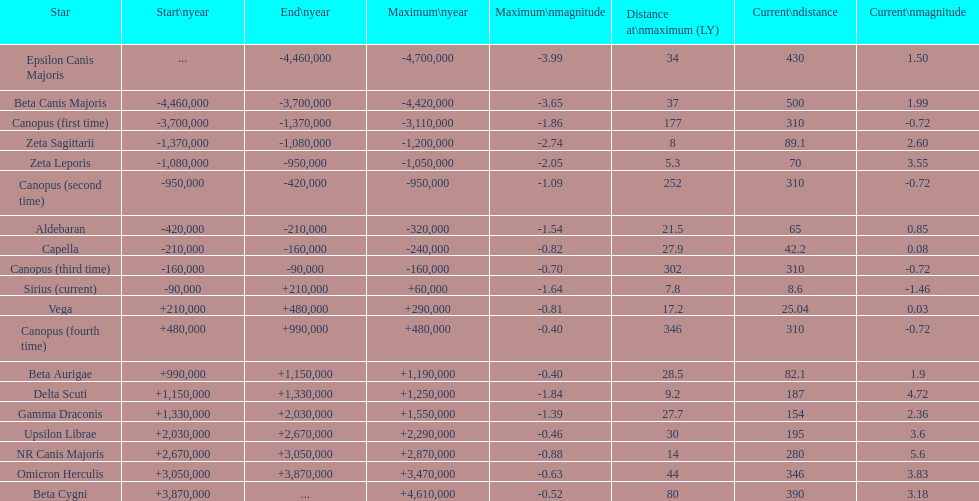Parse the full table. {'header': ['Star', 'Start\\nyear', 'End\\nyear', 'Maximum\\nyear', 'Maximum\\nmagnitude', 'Distance at\\nmaximum (LY)', 'Current\\ndistance', 'Current\\nmagnitude'], 'rows': [['Epsilon Canis Majoris', '...', '-4,460,000', '-4,700,000', '-3.99', '34', '430', '1.50'], ['Beta Canis Majoris', '-4,460,000', '-3,700,000', '-4,420,000', '-3.65', '37', '500', '1.99'], ['Canopus (first time)', '-3,700,000', '-1,370,000', '-3,110,000', '-1.86', '177', '310', '-0.72'], ['Zeta Sagittarii', '-1,370,000', '-1,080,000', '-1,200,000', '-2.74', '8', '89.1', '2.60'], ['Zeta Leporis', '-1,080,000', '-950,000', '-1,050,000', '-2.05', '5.3', '70', '3.55'], ['Canopus (second time)', '-950,000', '-420,000', '-950,000', '-1.09', '252', '310', '-0.72'], ['Aldebaran', '-420,000', '-210,000', '-320,000', '-1.54', '21.5', '65', '0.85'], ['Capella', '-210,000', '-160,000', '-240,000', '-0.82', '27.9', '42.2', '0.08'], ['Canopus (third time)', '-160,000', '-90,000', '-160,000', '-0.70', '302', '310', '-0.72'], ['Sirius (current)', '-90,000', '+210,000', '+60,000', '-1.64', '7.8', '8.6', '-1.46'], ['Vega', '+210,000', '+480,000', '+290,000', '-0.81', '17.2', '25.04', '0.03'], ['Canopus (fourth time)', '+480,000', '+990,000', '+480,000', '-0.40', '346', '310', '-0.72'], ['Beta Aurigae', '+990,000', '+1,150,000', '+1,190,000', '-0.40', '28.5', '82.1', '1.9'], ['Delta Scuti', '+1,150,000', '+1,330,000', '+1,250,000', '-1.84', '9.2', '187', '4.72'], ['Gamma Draconis', '+1,330,000', '+2,030,000', '+1,550,000', '-1.39', '27.7', '154', '2.36'], ['Upsilon Librae', '+2,030,000', '+2,670,000', '+2,290,000', '-0.46', '30', '195', '3.6'], ['NR Canis Majoris', '+2,670,000', '+3,050,000', '+2,870,000', '-0.88', '14', '280', '5.6'], ['Omicron Herculis', '+3,050,000', '+3,870,000', '+3,470,000', '-0.63', '44', '346', '3.83'], ['Beta Cygni', '+3,870,000', '...', '+4,610,000', '-0.52', '80', '390', '3.18']]} How much farther (in ly) is epsilon canis majoris than zeta sagittarii? 26. 